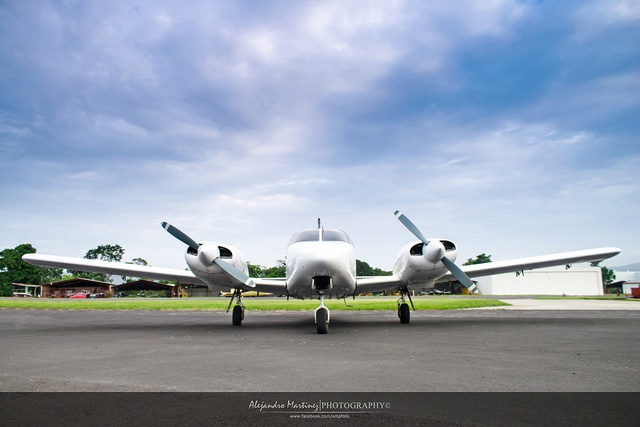Describe the objects in this image and their specific colors. I can see a airplane in gray, white, black, and darkgray tones in this image. 